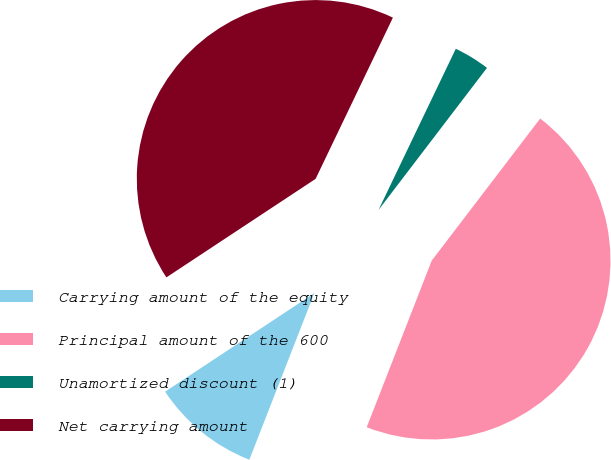<chart> <loc_0><loc_0><loc_500><loc_500><pie_chart><fcel>Carrying amount of the equity<fcel>Principal amount of the 600<fcel>Unamortized discount (1)<fcel>Net carrying amount<nl><fcel>9.79%<fcel>45.54%<fcel>3.26%<fcel>41.4%<nl></chart> 